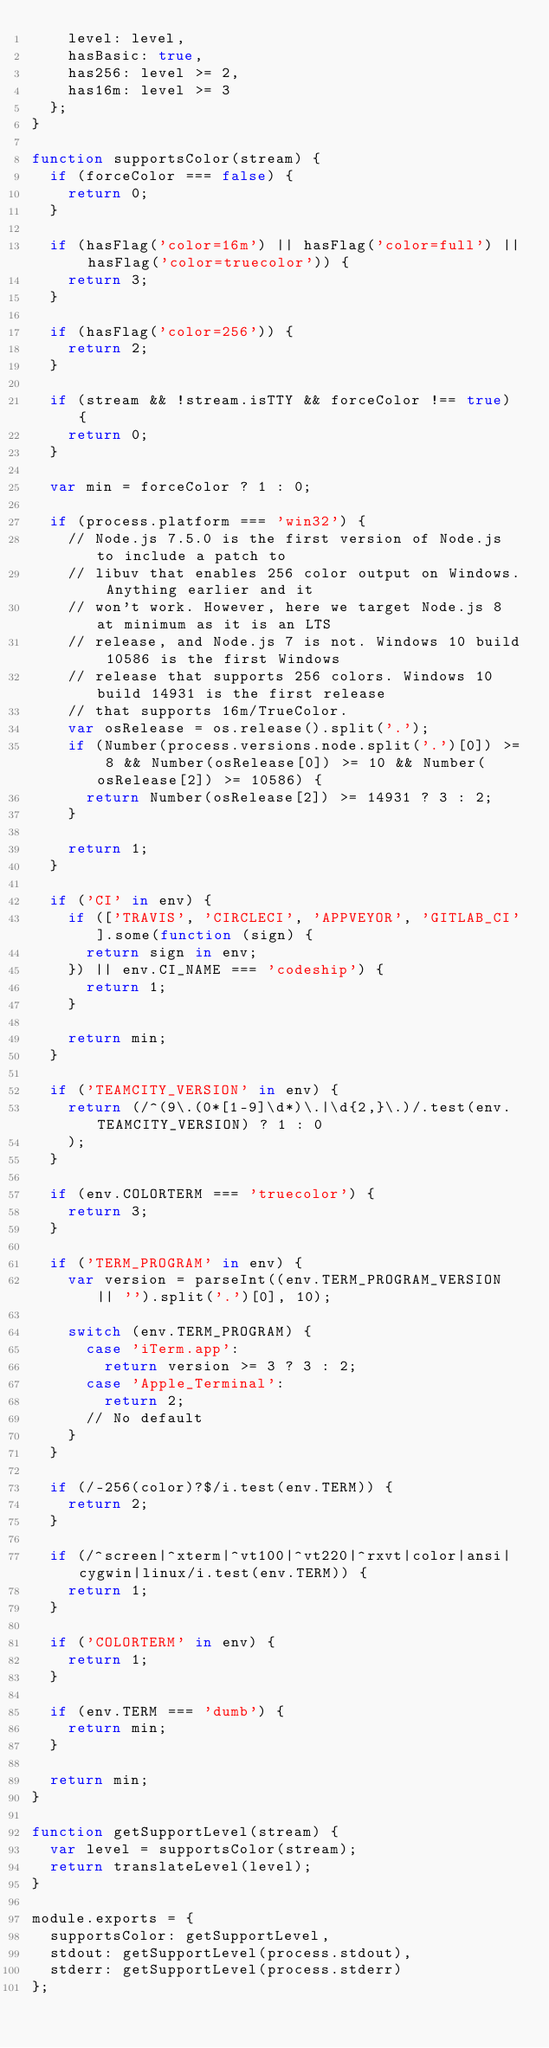Convert code to text. <code><loc_0><loc_0><loc_500><loc_500><_JavaScript_>		level: level,
		hasBasic: true,
		has256: level >= 2,
		has16m: level >= 3
	};
}

function supportsColor(stream) {
	if (forceColor === false) {
		return 0;
	}

	if (hasFlag('color=16m') || hasFlag('color=full') || hasFlag('color=truecolor')) {
		return 3;
	}

	if (hasFlag('color=256')) {
		return 2;
	}

	if (stream && !stream.isTTY && forceColor !== true) {
		return 0;
	}

	var min = forceColor ? 1 : 0;

	if (process.platform === 'win32') {
		// Node.js 7.5.0 is the first version of Node.js to include a patch to
		// libuv that enables 256 color output on Windows. Anything earlier and it
		// won't work. However, here we target Node.js 8 at minimum as it is an LTS
		// release, and Node.js 7 is not. Windows 10 build 10586 is the first Windows
		// release that supports 256 colors. Windows 10 build 14931 is the first release
		// that supports 16m/TrueColor.
		var osRelease = os.release().split('.');
		if (Number(process.versions.node.split('.')[0]) >= 8 && Number(osRelease[0]) >= 10 && Number(osRelease[2]) >= 10586) {
			return Number(osRelease[2]) >= 14931 ? 3 : 2;
		}

		return 1;
	}

	if ('CI' in env) {
		if (['TRAVIS', 'CIRCLECI', 'APPVEYOR', 'GITLAB_CI'].some(function (sign) {
			return sign in env;
		}) || env.CI_NAME === 'codeship') {
			return 1;
		}

		return min;
	}

	if ('TEAMCITY_VERSION' in env) {
		return (/^(9\.(0*[1-9]\d*)\.|\d{2,}\.)/.test(env.TEAMCITY_VERSION) ? 1 : 0
		);
	}

	if (env.COLORTERM === 'truecolor') {
		return 3;
	}

	if ('TERM_PROGRAM' in env) {
		var version = parseInt((env.TERM_PROGRAM_VERSION || '').split('.')[0], 10);

		switch (env.TERM_PROGRAM) {
			case 'iTerm.app':
				return version >= 3 ? 3 : 2;
			case 'Apple_Terminal':
				return 2;
			// No default
		}
	}

	if (/-256(color)?$/i.test(env.TERM)) {
		return 2;
	}

	if (/^screen|^xterm|^vt100|^vt220|^rxvt|color|ansi|cygwin|linux/i.test(env.TERM)) {
		return 1;
	}

	if ('COLORTERM' in env) {
		return 1;
	}

	if (env.TERM === 'dumb') {
		return min;
	}

	return min;
}

function getSupportLevel(stream) {
	var level = supportsColor(stream);
	return translateLevel(level);
}

module.exports = {
	supportsColor: getSupportLevel,
	stdout: getSupportLevel(process.stdout),
	stderr: getSupportLevel(process.stderr)
};</code> 